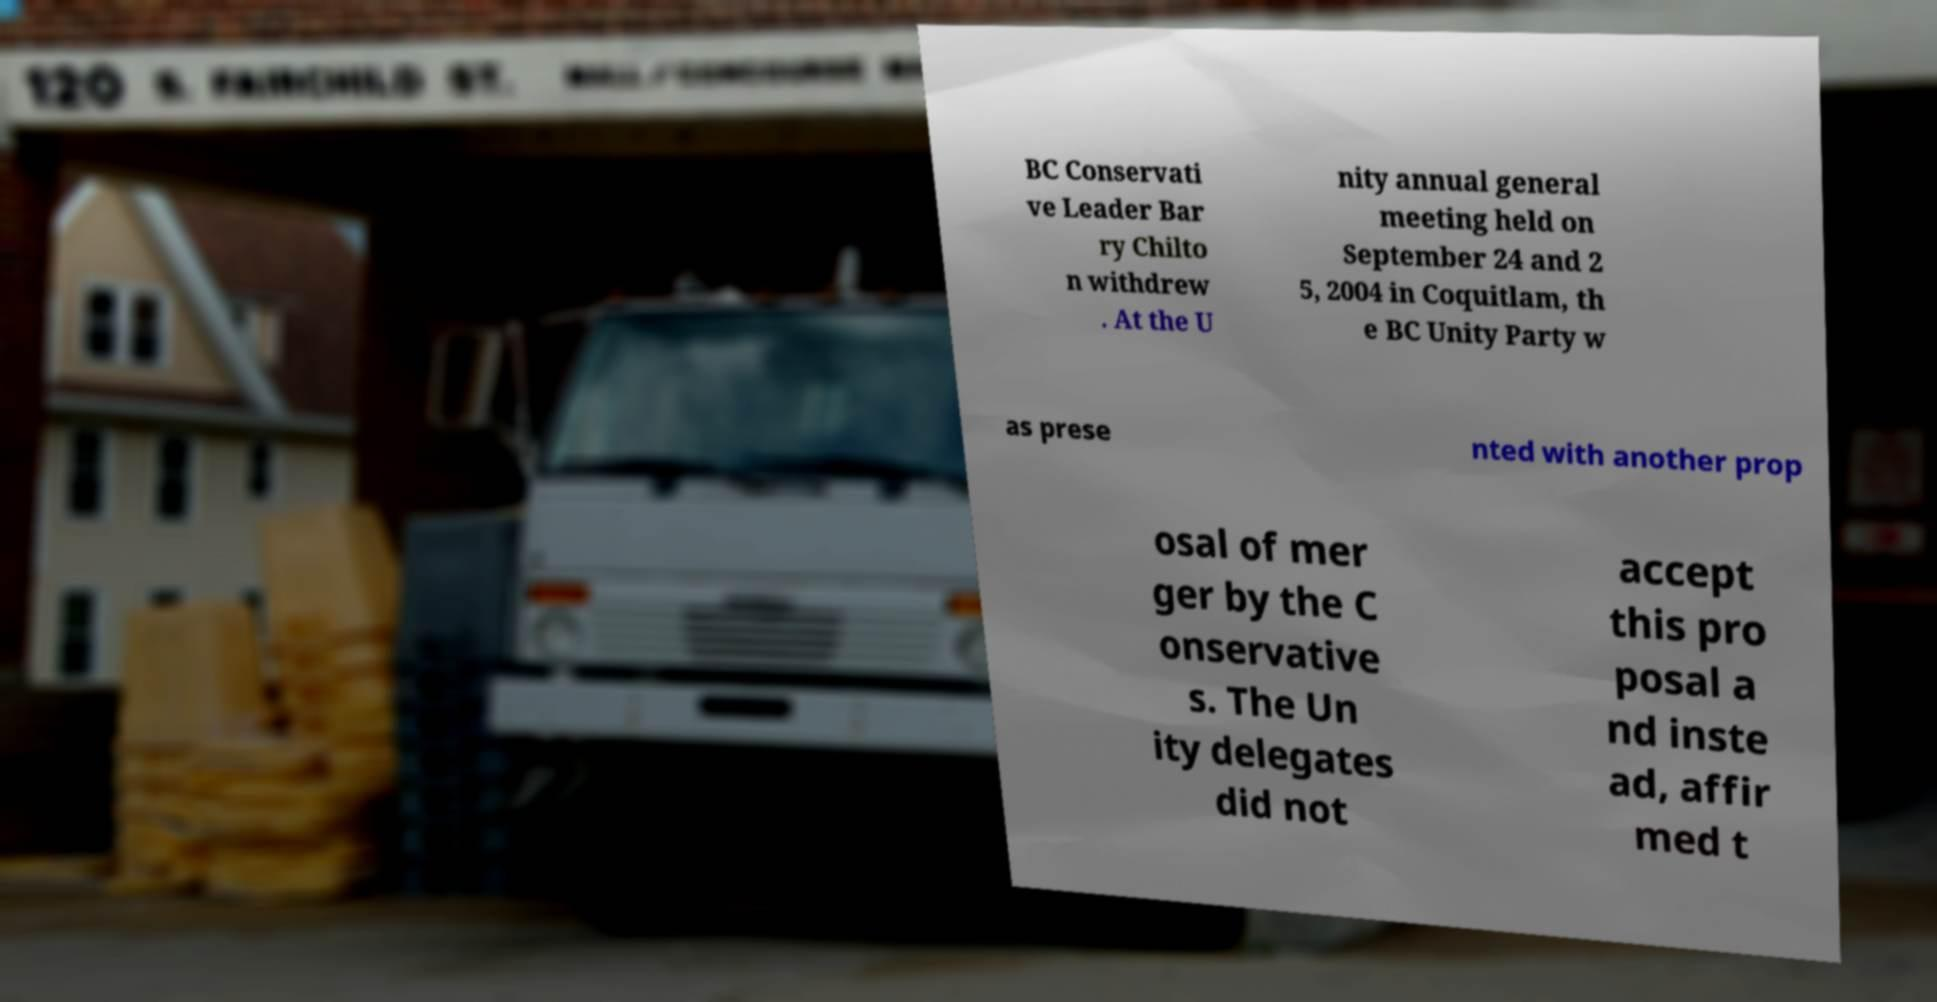There's text embedded in this image that I need extracted. Can you transcribe it verbatim? BC Conservati ve Leader Bar ry Chilto n withdrew . At the U nity annual general meeting held on September 24 and 2 5, 2004 in Coquitlam, th e BC Unity Party w as prese nted with another prop osal of mer ger by the C onservative s. The Un ity delegates did not accept this pro posal a nd inste ad, affir med t 